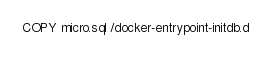Convert code to text. <code><loc_0><loc_0><loc_500><loc_500><_Dockerfile_>COPY micro.sql /docker-entrypoint-initdb.d
</code> 